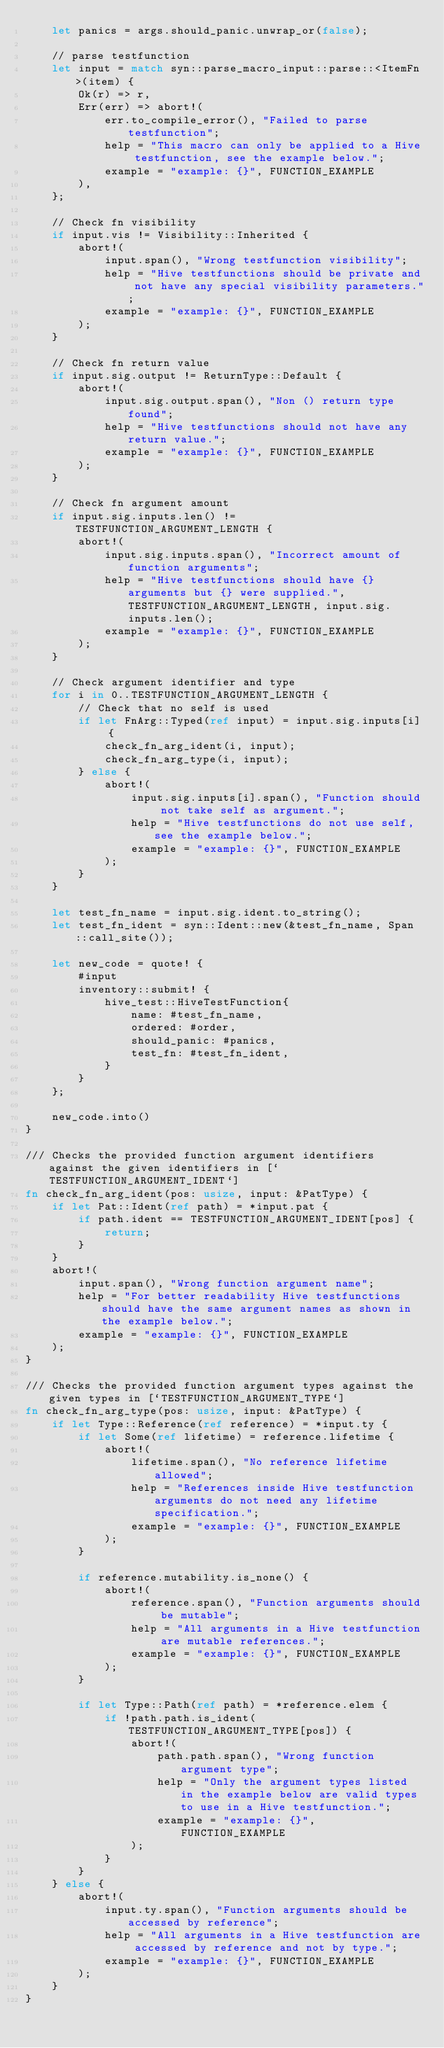Convert code to text. <code><loc_0><loc_0><loc_500><loc_500><_Rust_>    let panics = args.should_panic.unwrap_or(false);

    // parse testfunction
    let input = match syn::parse_macro_input::parse::<ItemFn>(item) {
        Ok(r) => r,
        Err(err) => abort!(
            err.to_compile_error(), "Failed to parse testfunction";
            help = "This macro can only be applied to a Hive testfunction, see the example below.";
            example = "example: {}", FUNCTION_EXAMPLE
        ),
    };

    // Check fn visibility
    if input.vis != Visibility::Inherited {
        abort!(
            input.span(), "Wrong testfunction visibility";
            help = "Hive testfunctions should be private and not have any special visibility parameters.";
            example = "example: {}", FUNCTION_EXAMPLE
        );
    }

    // Check fn return value
    if input.sig.output != ReturnType::Default {
        abort!(
            input.sig.output.span(), "Non () return type found";
            help = "Hive testfunctions should not have any return value.";
            example = "example: {}", FUNCTION_EXAMPLE
        );
    }

    // Check fn argument amount
    if input.sig.inputs.len() != TESTFUNCTION_ARGUMENT_LENGTH {
        abort!(
            input.sig.inputs.span(), "Incorrect amount of function arguments";
            help = "Hive testfunctions should have {} arguments but {} were supplied.", TESTFUNCTION_ARGUMENT_LENGTH, input.sig.inputs.len();
            example = "example: {}", FUNCTION_EXAMPLE
        );
    }

    // Check argument identifier and type
    for i in 0..TESTFUNCTION_ARGUMENT_LENGTH {
        // Check that no self is used
        if let FnArg::Typed(ref input) = input.sig.inputs[i] {
            check_fn_arg_ident(i, input);
            check_fn_arg_type(i, input);
        } else {
            abort!(
                input.sig.inputs[i].span(), "Function should not take self as argument.";
                help = "Hive testfunctions do not use self, see the example below.";
                example = "example: {}", FUNCTION_EXAMPLE
            );
        }
    }

    let test_fn_name = input.sig.ident.to_string();
    let test_fn_ident = syn::Ident::new(&test_fn_name, Span::call_site());

    let new_code = quote! {
        #input
        inventory::submit! {
            hive_test::HiveTestFunction{
                name: #test_fn_name,
                ordered: #order,
                should_panic: #panics,
                test_fn: #test_fn_ident,
            }
        }
    };

    new_code.into()
}

/// Checks the provided function argument identifiers against the given identifiers in [`TESTFUNCTION_ARGUMENT_IDENT`]
fn check_fn_arg_ident(pos: usize, input: &PatType) {
    if let Pat::Ident(ref path) = *input.pat {
        if path.ident == TESTFUNCTION_ARGUMENT_IDENT[pos] {
            return;
        }
    }
    abort!(
        input.span(), "Wrong function argument name";
        help = "For better readability Hive testfunctions should have the same argument names as shown in the example below.";
        example = "example: {}", FUNCTION_EXAMPLE
    );
}

/// Checks the provided function argument types against the given types in [`TESTFUNCTION_ARGUMENT_TYPE`]
fn check_fn_arg_type(pos: usize, input: &PatType) {
    if let Type::Reference(ref reference) = *input.ty {
        if let Some(ref lifetime) = reference.lifetime {
            abort!(
                lifetime.span(), "No reference lifetime allowed";
                help = "References inside Hive testfunction arguments do not need any lifetime specification.";
                example = "example: {}", FUNCTION_EXAMPLE
            );
        }

        if reference.mutability.is_none() {
            abort!(
                reference.span(), "Function arguments should be mutable";
                help = "All arguments in a Hive testfunction are mutable references.";
                example = "example: {}", FUNCTION_EXAMPLE
            );
        }

        if let Type::Path(ref path) = *reference.elem {
            if !path.path.is_ident(TESTFUNCTION_ARGUMENT_TYPE[pos]) {
                abort!(
                    path.path.span(), "Wrong function argument type";
                    help = "Only the argument types listed in the example below are valid types to use in a Hive testfunction.";
                    example = "example: {}", FUNCTION_EXAMPLE
                );
            }
        }
    } else {
        abort!(
            input.ty.span(), "Function arguments should be accessed by reference";
            help = "All arguments in a Hive testfunction are accessed by reference and not by type.";
            example = "example: {}", FUNCTION_EXAMPLE
        );
    }
}
</code> 